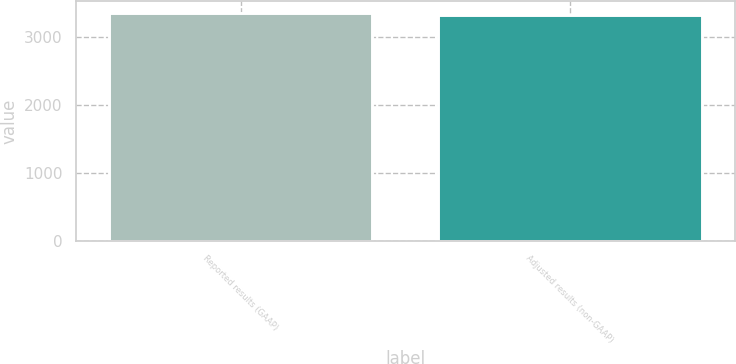Convert chart to OTSL. <chart><loc_0><loc_0><loc_500><loc_500><bar_chart><fcel>Reported results (GAAP)<fcel>Adjusted results (non-GAAP)<nl><fcel>3352<fcel>3316<nl></chart> 